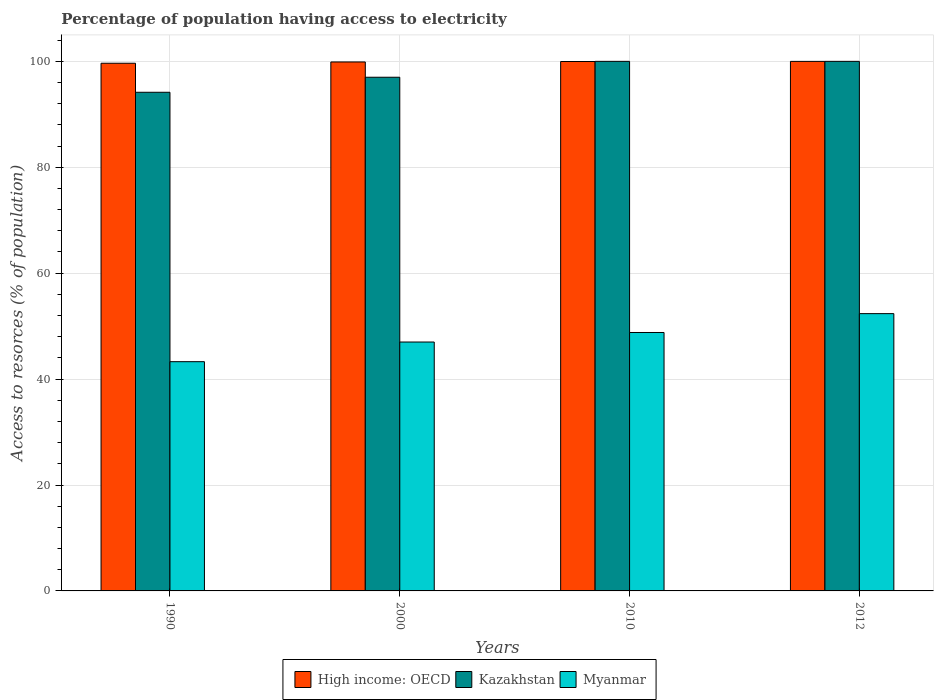How many different coloured bars are there?
Offer a terse response. 3. How many groups of bars are there?
Ensure brevity in your answer.  4. Are the number of bars per tick equal to the number of legend labels?
Provide a succinct answer. Yes. Are the number of bars on each tick of the X-axis equal?
Keep it short and to the point. Yes. How many bars are there on the 2nd tick from the left?
Make the answer very short. 3. How many bars are there on the 2nd tick from the right?
Make the answer very short. 3. In how many cases, is the number of bars for a given year not equal to the number of legend labels?
Provide a succinct answer. 0. What is the percentage of population having access to electricity in Kazakhstan in 1990?
Ensure brevity in your answer.  94.16. Across all years, what is the maximum percentage of population having access to electricity in High income: OECD?
Your answer should be compact. 99.99. Across all years, what is the minimum percentage of population having access to electricity in High income: OECD?
Make the answer very short. 99.64. In which year was the percentage of population having access to electricity in High income: OECD maximum?
Offer a terse response. 2012. What is the total percentage of population having access to electricity in Myanmar in the graph?
Ensure brevity in your answer.  191.45. What is the difference between the percentage of population having access to electricity in Myanmar in 2000 and that in 2012?
Offer a terse response. -5.36. What is the difference between the percentage of population having access to electricity in Myanmar in 2012 and the percentage of population having access to electricity in Kazakhstan in 1990?
Make the answer very short. -41.8. What is the average percentage of population having access to electricity in Myanmar per year?
Keep it short and to the point. 47.86. In the year 2012, what is the difference between the percentage of population having access to electricity in Myanmar and percentage of population having access to electricity in Kazakhstan?
Keep it short and to the point. -47.64. In how many years, is the percentage of population having access to electricity in Kazakhstan greater than 44 %?
Your answer should be compact. 4. Is the percentage of population having access to electricity in Kazakhstan in 2010 less than that in 2012?
Your response must be concise. No. What is the difference between the highest and the second highest percentage of population having access to electricity in Myanmar?
Make the answer very short. 3.56. What is the difference between the highest and the lowest percentage of population having access to electricity in Myanmar?
Your response must be concise. 9.07. In how many years, is the percentage of population having access to electricity in High income: OECD greater than the average percentage of population having access to electricity in High income: OECD taken over all years?
Give a very brief answer. 3. Is the sum of the percentage of population having access to electricity in High income: OECD in 1990 and 2010 greater than the maximum percentage of population having access to electricity in Kazakhstan across all years?
Your answer should be very brief. Yes. What does the 3rd bar from the left in 2000 represents?
Your answer should be compact. Myanmar. What does the 3rd bar from the right in 2010 represents?
Your response must be concise. High income: OECD. Is it the case that in every year, the sum of the percentage of population having access to electricity in Myanmar and percentage of population having access to electricity in High income: OECD is greater than the percentage of population having access to electricity in Kazakhstan?
Keep it short and to the point. Yes. How many years are there in the graph?
Make the answer very short. 4. What is the difference between two consecutive major ticks on the Y-axis?
Your answer should be very brief. 20. Does the graph contain grids?
Provide a succinct answer. Yes. Where does the legend appear in the graph?
Provide a short and direct response. Bottom center. How are the legend labels stacked?
Your response must be concise. Horizontal. What is the title of the graph?
Make the answer very short. Percentage of population having access to electricity. What is the label or title of the Y-axis?
Your response must be concise. Access to resorces (% of population). What is the Access to resorces (% of population) in High income: OECD in 1990?
Give a very brief answer. 99.64. What is the Access to resorces (% of population) in Kazakhstan in 1990?
Offer a terse response. 94.16. What is the Access to resorces (% of population) in Myanmar in 1990?
Provide a succinct answer. 43.29. What is the Access to resorces (% of population) of High income: OECD in 2000?
Provide a succinct answer. 99.89. What is the Access to resorces (% of population) in Kazakhstan in 2000?
Keep it short and to the point. 97. What is the Access to resorces (% of population) in High income: OECD in 2010?
Your answer should be very brief. 99.97. What is the Access to resorces (% of population) of Myanmar in 2010?
Your answer should be very brief. 48.8. What is the Access to resorces (% of population) in High income: OECD in 2012?
Offer a terse response. 99.99. What is the Access to resorces (% of population) of Kazakhstan in 2012?
Offer a terse response. 100. What is the Access to resorces (% of population) of Myanmar in 2012?
Ensure brevity in your answer.  52.36. Across all years, what is the maximum Access to resorces (% of population) of High income: OECD?
Your response must be concise. 99.99. Across all years, what is the maximum Access to resorces (% of population) in Myanmar?
Your answer should be compact. 52.36. Across all years, what is the minimum Access to resorces (% of population) of High income: OECD?
Your answer should be very brief. 99.64. Across all years, what is the minimum Access to resorces (% of population) in Kazakhstan?
Give a very brief answer. 94.16. Across all years, what is the minimum Access to resorces (% of population) in Myanmar?
Offer a terse response. 43.29. What is the total Access to resorces (% of population) of High income: OECD in the graph?
Your response must be concise. 399.49. What is the total Access to resorces (% of population) in Kazakhstan in the graph?
Provide a short and direct response. 391.16. What is the total Access to resorces (% of population) in Myanmar in the graph?
Offer a very short reply. 191.45. What is the difference between the Access to resorces (% of population) in High income: OECD in 1990 and that in 2000?
Offer a very short reply. -0.24. What is the difference between the Access to resorces (% of population) of Kazakhstan in 1990 and that in 2000?
Your answer should be very brief. -2.84. What is the difference between the Access to resorces (% of population) in Myanmar in 1990 and that in 2000?
Keep it short and to the point. -3.71. What is the difference between the Access to resorces (% of population) of High income: OECD in 1990 and that in 2010?
Your answer should be compact. -0.33. What is the difference between the Access to resorces (% of population) in Kazakhstan in 1990 and that in 2010?
Ensure brevity in your answer.  -5.84. What is the difference between the Access to resorces (% of population) in Myanmar in 1990 and that in 2010?
Provide a succinct answer. -5.51. What is the difference between the Access to resorces (% of population) of High income: OECD in 1990 and that in 2012?
Ensure brevity in your answer.  -0.35. What is the difference between the Access to resorces (% of population) of Kazakhstan in 1990 and that in 2012?
Your response must be concise. -5.84. What is the difference between the Access to resorces (% of population) of Myanmar in 1990 and that in 2012?
Ensure brevity in your answer.  -9.07. What is the difference between the Access to resorces (% of population) of High income: OECD in 2000 and that in 2010?
Offer a very short reply. -0.08. What is the difference between the Access to resorces (% of population) of Kazakhstan in 2000 and that in 2010?
Your answer should be very brief. -3. What is the difference between the Access to resorces (% of population) in Myanmar in 2000 and that in 2010?
Your answer should be very brief. -1.8. What is the difference between the Access to resorces (% of population) of High income: OECD in 2000 and that in 2012?
Make the answer very short. -0.11. What is the difference between the Access to resorces (% of population) in Myanmar in 2000 and that in 2012?
Offer a very short reply. -5.36. What is the difference between the Access to resorces (% of population) in High income: OECD in 2010 and that in 2012?
Ensure brevity in your answer.  -0.02. What is the difference between the Access to resorces (% of population) of Kazakhstan in 2010 and that in 2012?
Ensure brevity in your answer.  0. What is the difference between the Access to resorces (% of population) in Myanmar in 2010 and that in 2012?
Give a very brief answer. -3.56. What is the difference between the Access to resorces (% of population) of High income: OECD in 1990 and the Access to resorces (% of population) of Kazakhstan in 2000?
Your answer should be very brief. 2.64. What is the difference between the Access to resorces (% of population) of High income: OECD in 1990 and the Access to resorces (% of population) of Myanmar in 2000?
Keep it short and to the point. 52.64. What is the difference between the Access to resorces (% of population) of Kazakhstan in 1990 and the Access to resorces (% of population) of Myanmar in 2000?
Your answer should be compact. 47.16. What is the difference between the Access to resorces (% of population) of High income: OECD in 1990 and the Access to resorces (% of population) of Kazakhstan in 2010?
Provide a short and direct response. -0.36. What is the difference between the Access to resorces (% of population) in High income: OECD in 1990 and the Access to resorces (% of population) in Myanmar in 2010?
Make the answer very short. 50.84. What is the difference between the Access to resorces (% of population) of Kazakhstan in 1990 and the Access to resorces (% of population) of Myanmar in 2010?
Your answer should be very brief. 45.36. What is the difference between the Access to resorces (% of population) in High income: OECD in 1990 and the Access to resorces (% of population) in Kazakhstan in 2012?
Give a very brief answer. -0.36. What is the difference between the Access to resorces (% of population) of High income: OECD in 1990 and the Access to resorces (% of population) of Myanmar in 2012?
Provide a succinct answer. 47.28. What is the difference between the Access to resorces (% of population) of Kazakhstan in 1990 and the Access to resorces (% of population) of Myanmar in 2012?
Give a very brief answer. 41.8. What is the difference between the Access to resorces (% of population) of High income: OECD in 2000 and the Access to resorces (% of population) of Kazakhstan in 2010?
Your answer should be very brief. -0.11. What is the difference between the Access to resorces (% of population) of High income: OECD in 2000 and the Access to resorces (% of population) of Myanmar in 2010?
Keep it short and to the point. 51.09. What is the difference between the Access to resorces (% of population) in Kazakhstan in 2000 and the Access to resorces (% of population) in Myanmar in 2010?
Make the answer very short. 48.2. What is the difference between the Access to resorces (% of population) of High income: OECD in 2000 and the Access to resorces (% of population) of Kazakhstan in 2012?
Provide a succinct answer. -0.11. What is the difference between the Access to resorces (% of population) in High income: OECD in 2000 and the Access to resorces (% of population) in Myanmar in 2012?
Provide a succinct answer. 47.52. What is the difference between the Access to resorces (% of population) of Kazakhstan in 2000 and the Access to resorces (% of population) of Myanmar in 2012?
Offer a terse response. 44.64. What is the difference between the Access to resorces (% of population) of High income: OECD in 2010 and the Access to resorces (% of population) of Kazakhstan in 2012?
Ensure brevity in your answer.  -0.03. What is the difference between the Access to resorces (% of population) of High income: OECD in 2010 and the Access to resorces (% of population) of Myanmar in 2012?
Your answer should be compact. 47.61. What is the difference between the Access to resorces (% of population) in Kazakhstan in 2010 and the Access to resorces (% of population) in Myanmar in 2012?
Make the answer very short. 47.64. What is the average Access to resorces (% of population) of High income: OECD per year?
Keep it short and to the point. 99.87. What is the average Access to resorces (% of population) in Kazakhstan per year?
Your response must be concise. 97.79. What is the average Access to resorces (% of population) in Myanmar per year?
Offer a terse response. 47.86. In the year 1990, what is the difference between the Access to resorces (% of population) in High income: OECD and Access to resorces (% of population) in Kazakhstan?
Offer a terse response. 5.48. In the year 1990, what is the difference between the Access to resorces (% of population) in High income: OECD and Access to resorces (% of population) in Myanmar?
Your response must be concise. 56.36. In the year 1990, what is the difference between the Access to resorces (% of population) in Kazakhstan and Access to resorces (% of population) in Myanmar?
Keep it short and to the point. 50.87. In the year 2000, what is the difference between the Access to resorces (% of population) in High income: OECD and Access to resorces (% of population) in Kazakhstan?
Your response must be concise. 2.89. In the year 2000, what is the difference between the Access to resorces (% of population) in High income: OECD and Access to resorces (% of population) in Myanmar?
Offer a very short reply. 52.89. In the year 2010, what is the difference between the Access to resorces (% of population) in High income: OECD and Access to resorces (% of population) in Kazakhstan?
Give a very brief answer. -0.03. In the year 2010, what is the difference between the Access to resorces (% of population) in High income: OECD and Access to resorces (% of population) in Myanmar?
Your answer should be compact. 51.17. In the year 2010, what is the difference between the Access to resorces (% of population) in Kazakhstan and Access to resorces (% of population) in Myanmar?
Your response must be concise. 51.2. In the year 2012, what is the difference between the Access to resorces (% of population) of High income: OECD and Access to resorces (% of population) of Kazakhstan?
Your answer should be very brief. -0.01. In the year 2012, what is the difference between the Access to resorces (% of population) of High income: OECD and Access to resorces (% of population) of Myanmar?
Keep it short and to the point. 47.63. In the year 2012, what is the difference between the Access to resorces (% of population) in Kazakhstan and Access to resorces (% of population) in Myanmar?
Provide a succinct answer. 47.64. What is the ratio of the Access to resorces (% of population) of Kazakhstan in 1990 to that in 2000?
Provide a short and direct response. 0.97. What is the ratio of the Access to resorces (% of population) in Myanmar in 1990 to that in 2000?
Keep it short and to the point. 0.92. What is the ratio of the Access to resorces (% of population) in High income: OECD in 1990 to that in 2010?
Provide a short and direct response. 1. What is the ratio of the Access to resorces (% of population) in Kazakhstan in 1990 to that in 2010?
Offer a very short reply. 0.94. What is the ratio of the Access to resorces (% of population) in Myanmar in 1990 to that in 2010?
Offer a very short reply. 0.89. What is the ratio of the Access to resorces (% of population) in Kazakhstan in 1990 to that in 2012?
Provide a short and direct response. 0.94. What is the ratio of the Access to resorces (% of population) of Myanmar in 1990 to that in 2012?
Your response must be concise. 0.83. What is the ratio of the Access to resorces (% of population) of High income: OECD in 2000 to that in 2010?
Make the answer very short. 1. What is the ratio of the Access to resorces (% of population) in Myanmar in 2000 to that in 2010?
Provide a short and direct response. 0.96. What is the ratio of the Access to resorces (% of population) in Kazakhstan in 2000 to that in 2012?
Ensure brevity in your answer.  0.97. What is the ratio of the Access to resorces (% of population) in Myanmar in 2000 to that in 2012?
Offer a very short reply. 0.9. What is the ratio of the Access to resorces (% of population) of High income: OECD in 2010 to that in 2012?
Your answer should be compact. 1. What is the ratio of the Access to resorces (% of population) of Myanmar in 2010 to that in 2012?
Your answer should be compact. 0.93. What is the difference between the highest and the second highest Access to resorces (% of population) of High income: OECD?
Your response must be concise. 0.02. What is the difference between the highest and the second highest Access to resorces (% of population) in Myanmar?
Your answer should be very brief. 3.56. What is the difference between the highest and the lowest Access to resorces (% of population) in High income: OECD?
Make the answer very short. 0.35. What is the difference between the highest and the lowest Access to resorces (% of population) of Kazakhstan?
Ensure brevity in your answer.  5.84. What is the difference between the highest and the lowest Access to resorces (% of population) of Myanmar?
Keep it short and to the point. 9.07. 